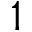<formula> <loc_0><loc_0><loc_500><loc_500>1</formula> 